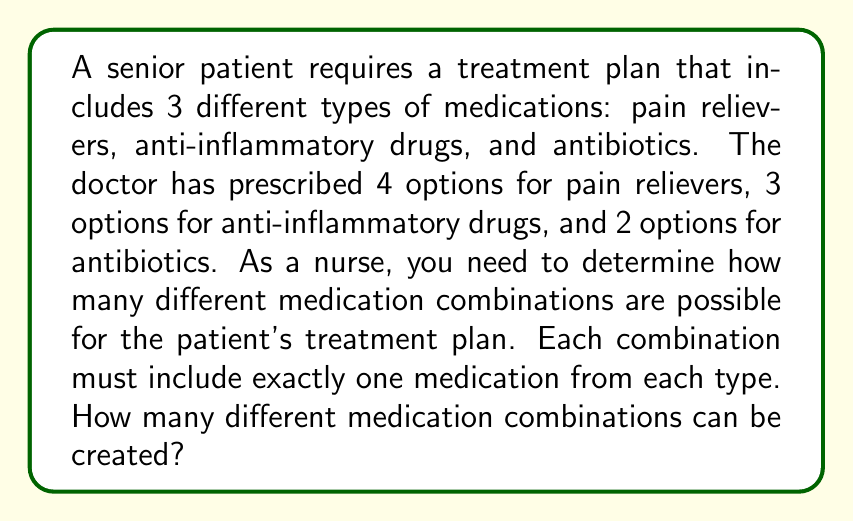Teach me how to tackle this problem. To solve this problem, we'll use the multiplication principle of counting. This principle states that if we have a series of choices, and each choice is independent of the others, we multiply the number of options for each choice to get the total number of possible combinations.

Let's break down the problem:

1. Pain relievers: 4 options
2. Anti-inflammatory drugs: 3 options
3. Antibiotics: 2 options

For each combination, we need to choose:
- 1 pain reliever out of 4 options
- 1 anti-inflammatory drug out of 3 options
- 1 antibiotic out of 2 options

Using the multiplication principle:

Total number of combinations = (Number of pain reliever options) × (Number of anti-inflammatory drug options) × (Number of antibiotic options)

$$ \text{Total combinations} = 4 \times 3 \times 2 $$

$$ \text{Total combinations} = 24 $$

Therefore, there are 24 different medication combinations possible for the patient's treatment plan.
Answer: 24 combinations 